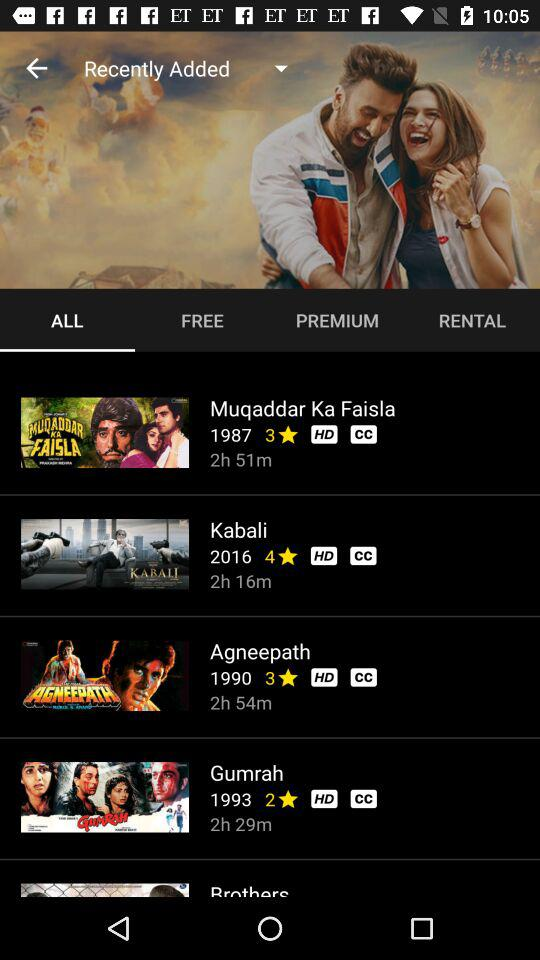What is the duration of the movie "Gumrah"? The duration is 2 hours and 29 minutes. 